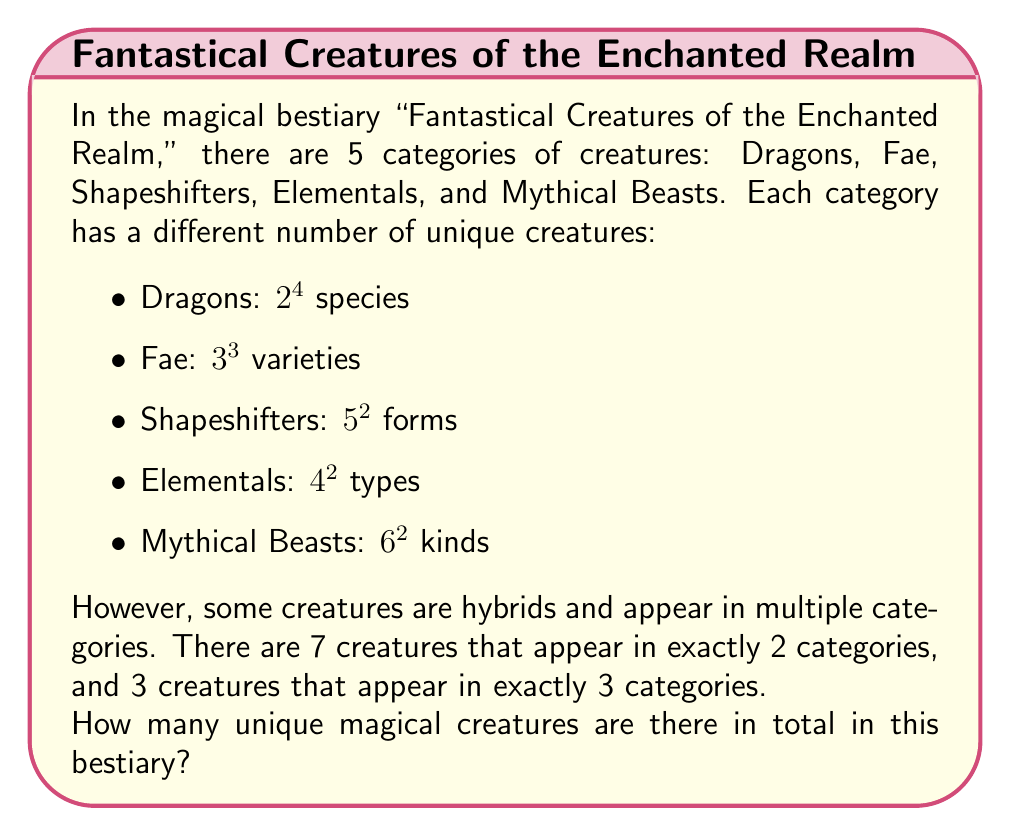Show me your answer to this math problem. Let's approach this problem step by step:

1. First, let's calculate the number of creatures in each category:

   Dragons: $2^4 = 16$
   Fae: $3^3 = 27$
   Shapeshifters: $5^2 = 25$
   Elementals: $4^2 = 16$
   Mythical Beasts: $6^2 = 36$

2. Now, let's sum up all these numbers:

   $16 + 27 + 25 + 16 + 36 = 120$

3. However, this sum includes the hybrid creatures multiple times. We need to subtract these duplicates.

4. For creatures appearing in exactly 2 categories:
   There are 7 such creatures, and each is counted twice in our sum.
   We need to subtract 7 to count them only once: $7 \times 1 = 7$

5. For creatures appearing in exactly 3 categories:
   There are 3 such creatures, and each is counted three times in our sum.
   We need to subtract 6 to count them only once: $3 \times 2 = 6$

6. The total number of unique creatures is:

   $120 - 7 - 6 = 107$

Therefore, there are 107 unique magical creatures in the bestiary.
Answer: 107 unique magical creatures 